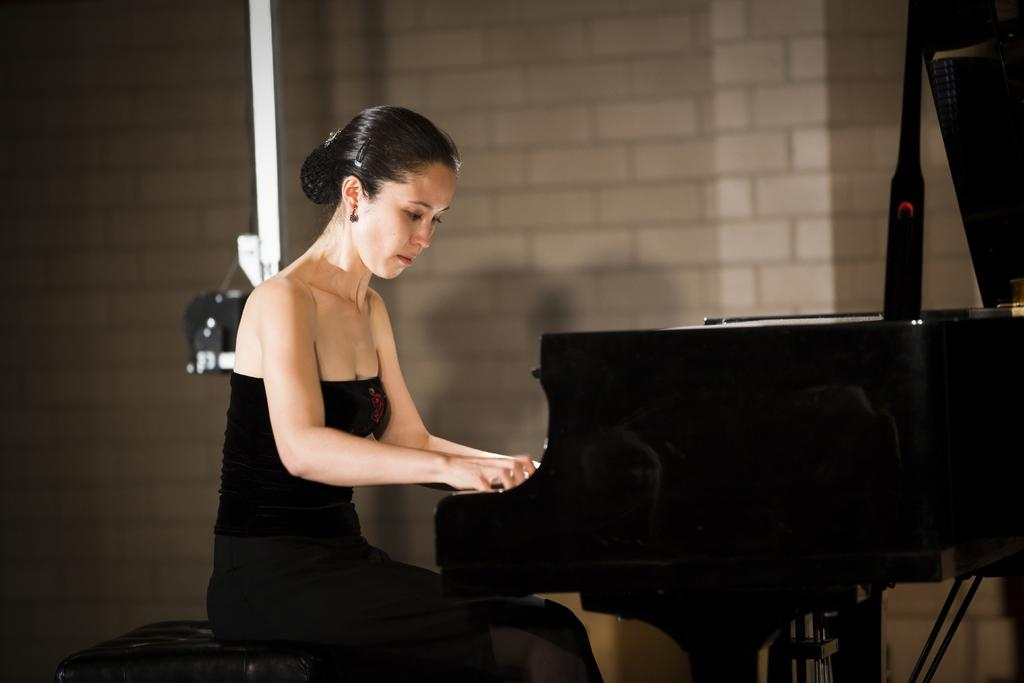Who is the main subject in the image? There is a woman in the image. What is the woman doing in the image? The woman is playing a piano. Where is the woman sitting while playing the piano? The woman is sitting on a sofa. What is the woman's desire for the fire in the image? There is no fire present in the image, so it is not possible to determine the woman's desire for a fire. 